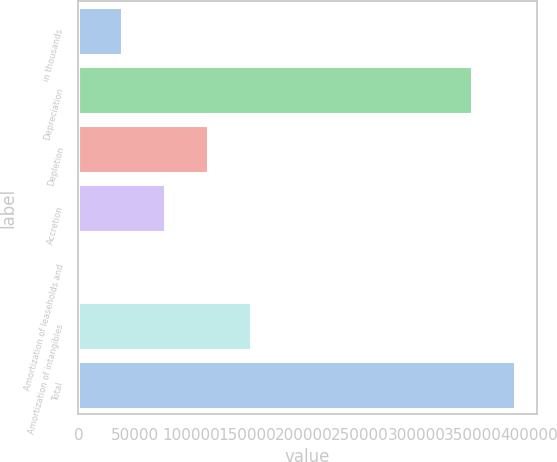Convert chart. <chart><loc_0><loc_0><loc_500><loc_500><bar_chart><fcel>in thousands<fcel>Depreciation<fcel>Depletion<fcel>Accretion<fcel>Amortization of leaseholds and<fcel>Amortization of intangibles<fcel>Total<nl><fcel>38384.8<fcel>349460<fcel>114764<fcel>76574.6<fcel>195<fcel>152954<fcel>387650<nl></chart> 